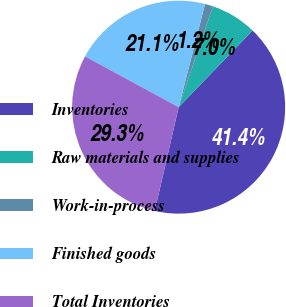Convert chart. <chart><loc_0><loc_0><loc_500><loc_500><pie_chart><fcel>Inventories<fcel>Raw materials and supplies<fcel>Work-in-process<fcel>Finished goods<fcel>Total Inventories<nl><fcel>41.39%<fcel>6.99%<fcel>1.23%<fcel>21.08%<fcel>29.3%<nl></chart> 